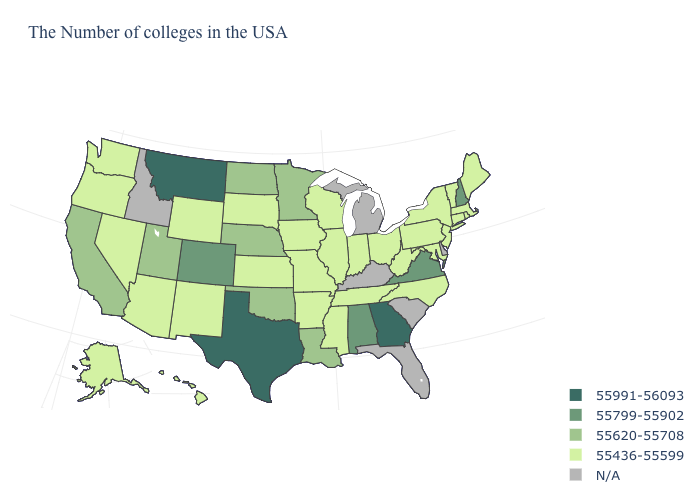Name the states that have a value in the range 55799-55902?
Short answer required. New Hampshire, Virginia, Alabama, Colorado. What is the value of California?
Write a very short answer. 55620-55708. How many symbols are there in the legend?
Quick response, please. 5. Name the states that have a value in the range 55620-55708?
Quick response, please. Louisiana, Minnesota, Nebraska, Oklahoma, North Dakota, Utah, California. Name the states that have a value in the range 55620-55708?
Answer briefly. Louisiana, Minnesota, Nebraska, Oklahoma, North Dakota, Utah, California. Name the states that have a value in the range 55436-55599?
Give a very brief answer. Maine, Massachusetts, Rhode Island, Vermont, Connecticut, New York, New Jersey, Maryland, Pennsylvania, North Carolina, West Virginia, Ohio, Indiana, Tennessee, Wisconsin, Illinois, Mississippi, Missouri, Arkansas, Iowa, Kansas, South Dakota, Wyoming, New Mexico, Arizona, Nevada, Washington, Oregon, Alaska, Hawaii. Name the states that have a value in the range 55436-55599?
Concise answer only. Maine, Massachusetts, Rhode Island, Vermont, Connecticut, New York, New Jersey, Maryland, Pennsylvania, North Carolina, West Virginia, Ohio, Indiana, Tennessee, Wisconsin, Illinois, Mississippi, Missouri, Arkansas, Iowa, Kansas, South Dakota, Wyoming, New Mexico, Arizona, Nevada, Washington, Oregon, Alaska, Hawaii. What is the value of Delaware?
Write a very short answer. N/A. Among the states that border Connecticut , which have the lowest value?
Give a very brief answer. Massachusetts, Rhode Island, New York. What is the lowest value in states that border New Jersey?
Quick response, please. 55436-55599. How many symbols are there in the legend?
Give a very brief answer. 5. Which states have the lowest value in the USA?
Answer briefly. Maine, Massachusetts, Rhode Island, Vermont, Connecticut, New York, New Jersey, Maryland, Pennsylvania, North Carolina, West Virginia, Ohio, Indiana, Tennessee, Wisconsin, Illinois, Mississippi, Missouri, Arkansas, Iowa, Kansas, South Dakota, Wyoming, New Mexico, Arizona, Nevada, Washington, Oregon, Alaska, Hawaii. Which states have the lowest value in the Northeast?
Answer briefly. Maine, Massachusetts, Rhode Island, Vermont, Connecticut, New York, New Jersey, Pennsylvania. Which states have the lowest value in the West?
Quick response, please. Wyoming, New Mexico, Arizona, Nevada, Washington, Oregon, Alaska, Hawaii. 